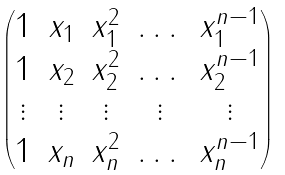Convert formula to latex. <formula><loc_0><loc_0><loc_500><loc_500>\begin{pmatrix} 1 & x _ { 1 } & x _ { 1 } ^ { 2 } & \dots & x _ { 1 } ^ { n - 1 } \\ 1 & x _ { 2 } & x _ { 2 } ^ { 2 } & \dots & x _ { 2 } ^ { n - 1 } \\ \vdots & \vdots & \vdots & \vdots & \vdots \\ 1 & x _ { n } & x _ { n } ^ { 2 } & \dots & x _ { n } ^ { n - 1 } \end{pmatrix}</formula> 